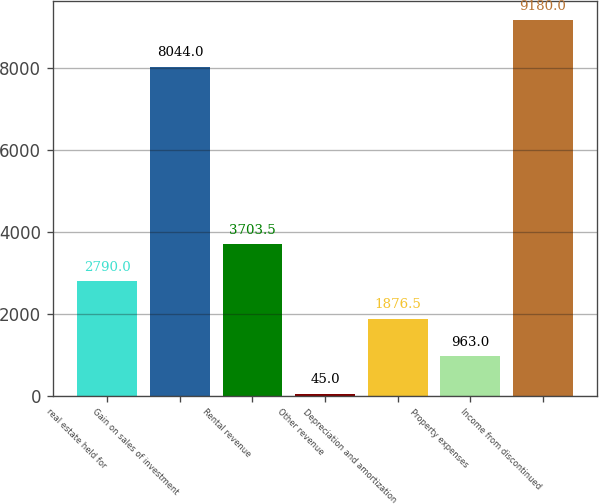<chart> <loc_0><loc_0><loc_500><loc_500><bar_chart><fcel>real estate held for<fcel>Gain on sales of investment<fcel>Rental revenue<fcel>Other revenue<fcel>Depreciation and amortization<fcel>Property expenses<fcel>Income from discontinued<nl><fcel>2790<fcel>8044<fcel>3703.5<fcel>45<fcel>1876.5<fcel>963<fcel>9180<nl></chart> 